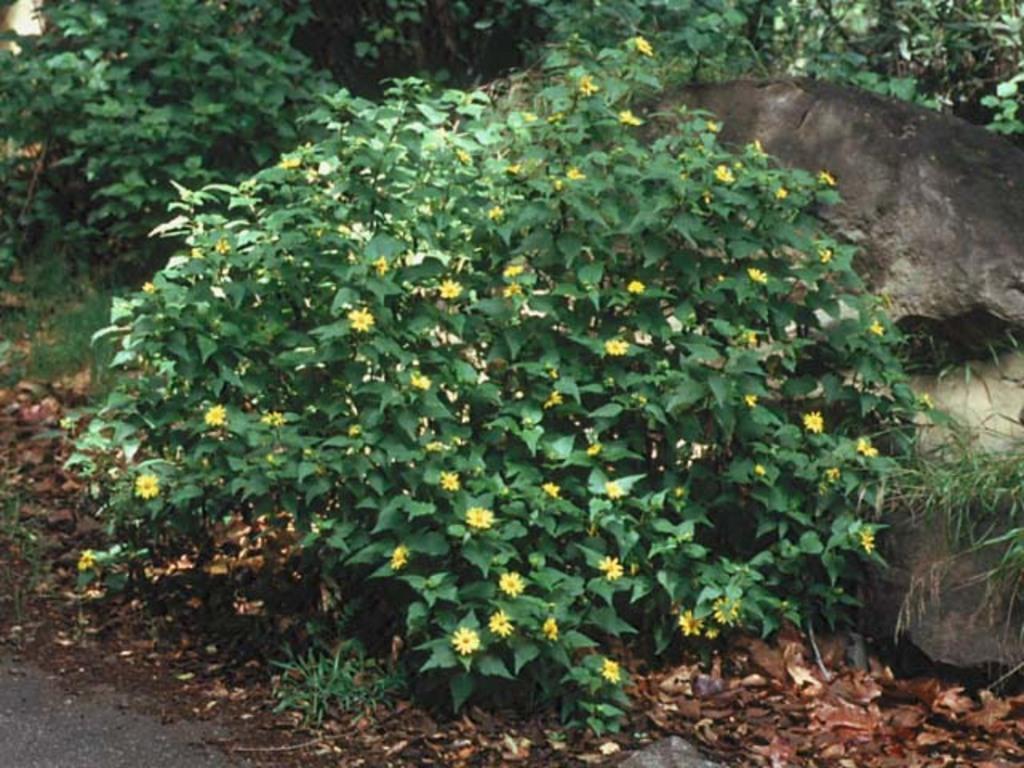In one or two sentences, can you explain what this image depicts? In the image there are few flowering plants and also some grass, behind the plants on the right side there is a rock. 